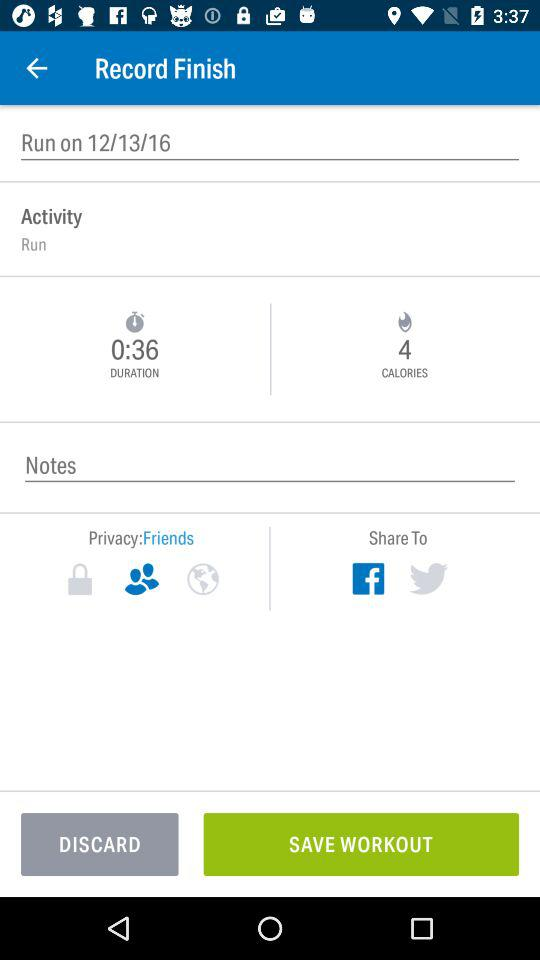What is the time duration recorded for the activity? The time duration recorded for the activity is 36 seconds. 